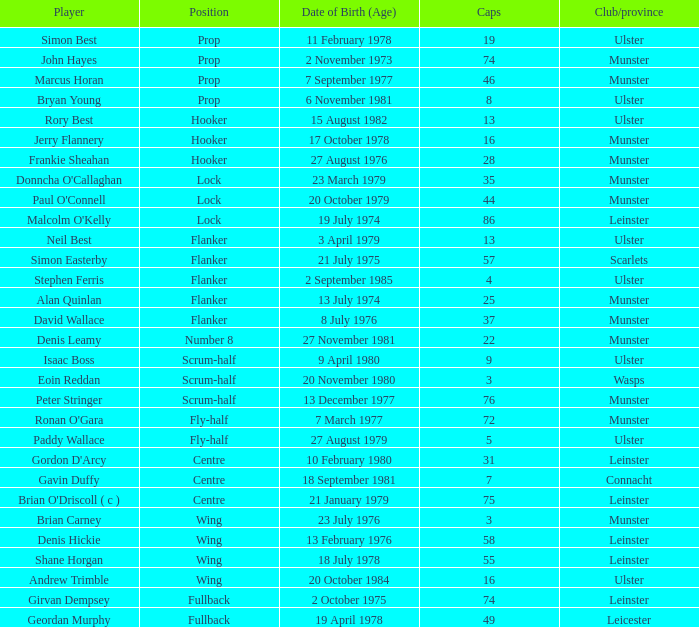What is the club or province of Girvan Dempsey, who has 74 caps? Leinster. I'm looking to parse the entire table for insights. Could you assist me with that? {'header': ['Player', 'Position', 'Date of Birth (Age)', 'Caps', 'Club/province'], 'rows': [['Simon Best', 'Prop', '11 February 1978', '19', 'Ulster'], ['John Hayes', 'Prop', '2 November 1973', '74', 'Munster'], ['Marcus Horan', 'Prop', '7 September 1977', '46', 'Munster'], ['Bryan Young', 'Prop', '6 November 1981', '8', 'Ulster'], ['Rory Best', 'Hooker', '15 August 1982', '13', 'Ulster'], ['Jerry Flannery', 'Hooker', '17 October 1978', '16', 'Munster'], ['Frankie Sheahan', 'Hooker', '27 August 1976', '28', 'Munster'], ["Donncha O'Callaghan", 'Lock', '23 March 1979', '35', 'Munster'], ["Paul O'Connell", 'Lock', '20 October 1979', '44', 'Munster'], ["Malcolm O'Kelly", 'Lock', '19 July 1974', '86', 'Leinster'], ['Neil Best', 'Flanker', '3 April 1979', '13', 'Ulster'], ['Simon Easterby', 'Flanker', '21 July 1975', '57', 'Scarlets'], ['Stephen Ferris', 'Flanker', '2 September 1985', '4', 'Ulster'], ['Alan Quinlan', 'Flanker', '13 July 1974', '25', 'Munster'], ['David Wallace', 'Flanker', '8 July 1976', '37', 'Munster'], ['Denis Leamy', 'Number 8', '27 November 1981', '22', 'Munster'], ['Isaac Boss', 'Scrum-half', '9 April 1980', '9', 'Ulster'], ['Eoin Reddan', 'Scrum-half', '20 November 1980', '3', 'Wasps'], ['Peter Stringer', 'Scrum-half', '13 December 1977', '76', 'Munster'], ["Ronan O'Gara", 'Fly-half', '7 March 1977', '72', 'Munster'], ['Paddy Wallace', 'Fly-half', '27 August 1979', '5', 'Ulster'], ["Gordon D'Arcy", 'Centre', '10 February 1980', '31', 'Leinster'], ['Gavin Duffy', 'Centre', '18 September 1981', '7', 'Connacht'], ["Brian O'Driscoll ( c )", 'Centre', '21 January 1979', '75', 'Leinster'], ['Brian Carney', 'Wing', '23 July 1976', '3', 'Munster'], ['Denis Hickie', 'Wing', '13 February 1976', '58', 'Leinster'], ['Shane Horgan', 'Wing', '18 July 1978', '55', 'Leinster'], ['Andrew Trimble', 'Wing', '20 October 1984', '16', 'Ulster'], ['Girvan Dempsey', 'Fullback', '2 October 1975', '74', 'Leinster'], ['Geordan Murphy', 'Fullback', '19 April 1978', '49', 'Leicester']]} 